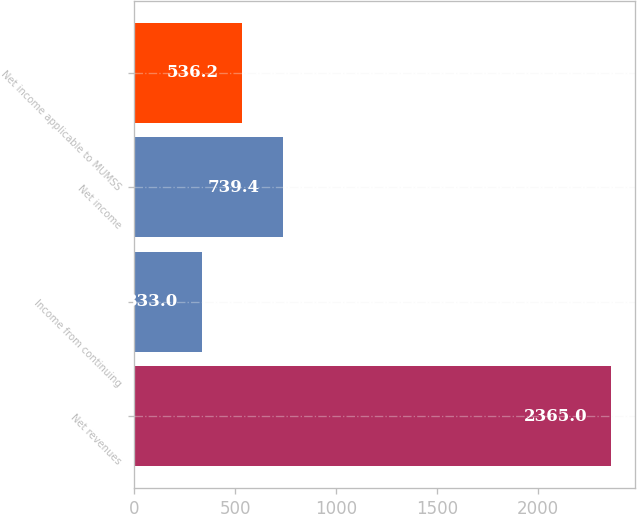<chart> <loc_0><loc_0><loc_500><loc_500><bar_chart><fcel>Net revenues<fcel>Income from continuing<fcel>Net income<fcel>Net income applicable to MUMSS<nl><fcel>2365<fcel>333<fcel>739.4<fcel>536.2<nl></chart> 